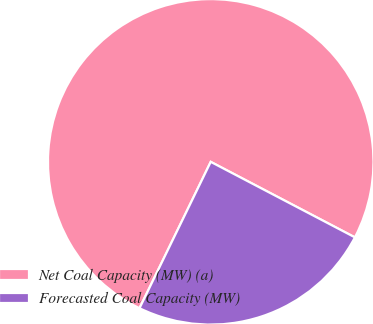Convert chart to OTSL. <chart><loc_0><loc_0><loc_500><loc_500><pie_chart><fcel>Net Coal Capacity (MW) (a)<fcel>Forecasted Coal Capacity (MW)<nl><fcel>75.47%<fcel>24.53%<nl></chart> 